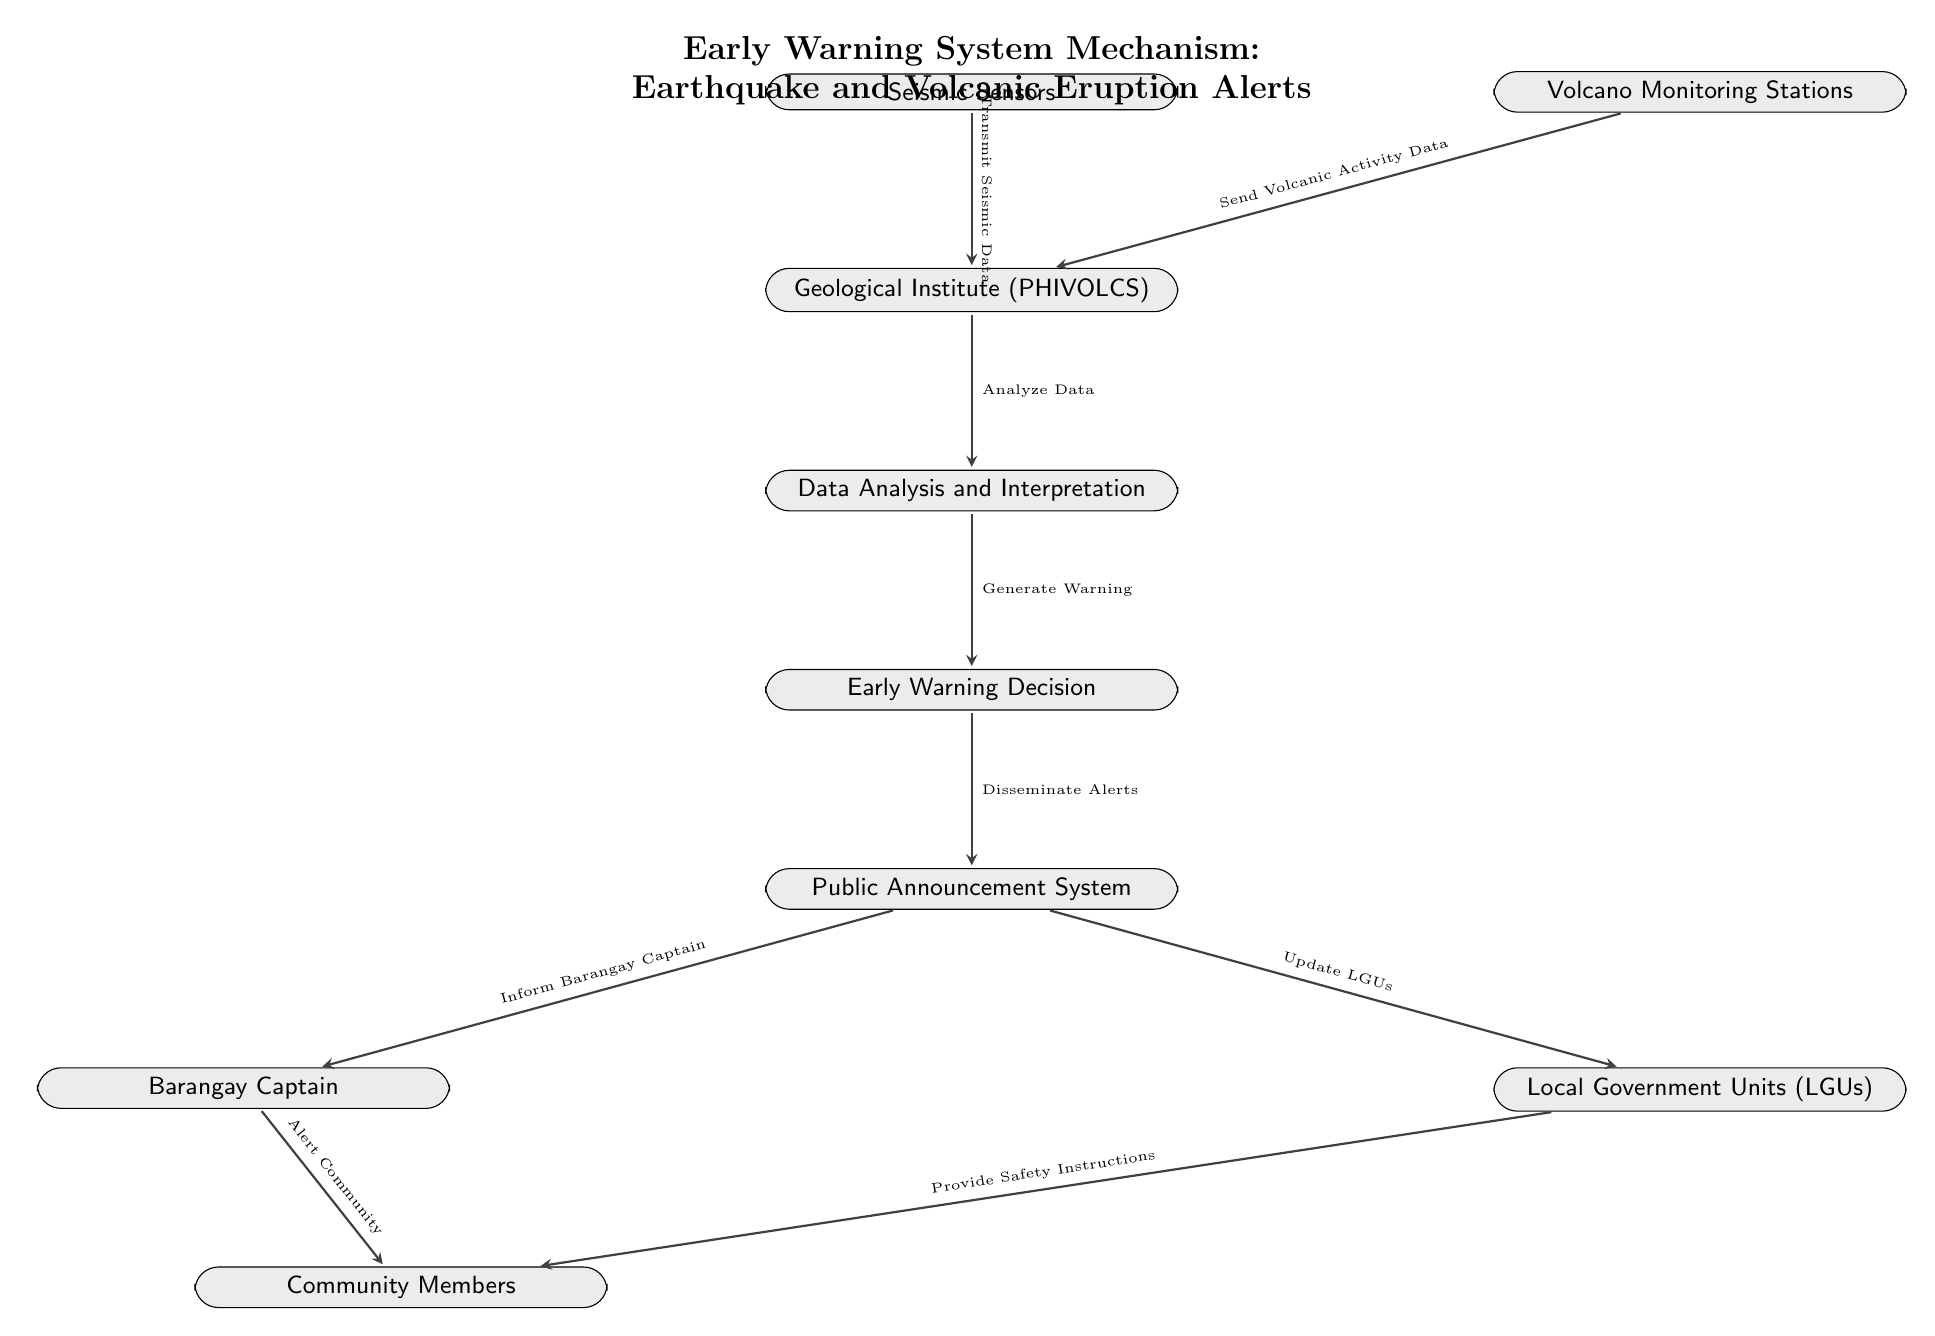What are the two sources of data input to the Geological Institute? The diagram shows two input nodes: "Seismic Sensors" and "Volcano Monitoring Stations" both of which feed data into the "Geological Institute (PHIVOLCS)."
Answer: Seismic Sensors and Volcano Monitoring Stations What occurs after the data is analyzed by the Geological Institute? According to the flowchart, after analyzing the data, the next step is "Data Analysis and Interpretation," which leads to the "Early Warning Decision."
Answer: Early Warning Decision How many steps are there from "Public Announcement System" to "Community Members"? The flowchart indicates that there are two direct steps: first from "Public Announcement System" to "Barangay Captain" and "Local Government Units (LGUs)," and then both of these nodes immediately lead to "Community Members."
Answer: 2 Which node is responsible for disseminating alerts? In the diagram, the node labeled "Early Warning Decision" is directly connected to "Public Announcement System," which is responsible for disseminating alerts to the community.
Answer: Public Announcement System What action does the Barangay Captain take after being informed? Once informed by the Public Announcement System, the Barangay Captain takes action by alerting the Community Members. The flow indicates this transition clearly.
Answer: Alert Community 